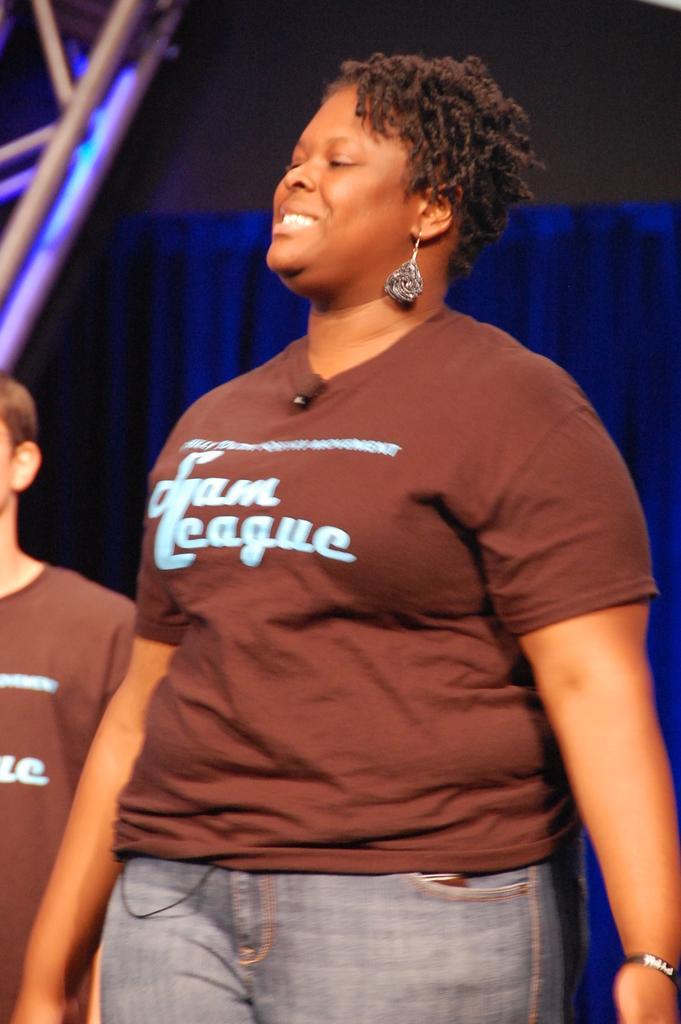Please provide a concise description of this image. In the picture I can see two persons are standing. These people are wearing t-shirts. On these t-shirts I can see something written on them. In the background I can see some other objects. 